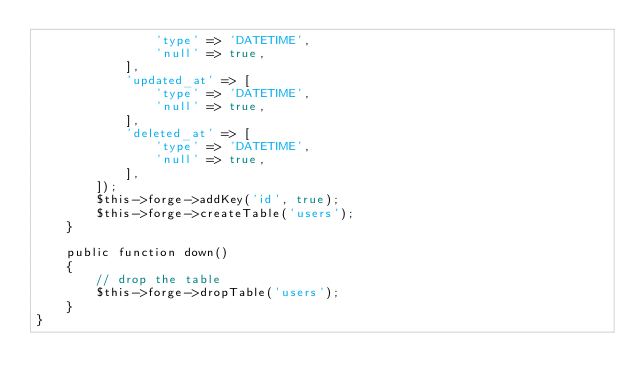<code> <loc_0><loc_0><loc_500><loc_500><_PHP_>                'type' => 'DATETIME',
                'null' => true,
            ],
            'updated_at' => [
                'type' => 'DATETIME',
                'null' => true,
            ],
            'deleted_at' => [
                'type' => 'DATETIME',
                'null' => true,
            ],
        ]);
        $this->forge->addKey('id', true);
        $this->forge->createTable('users');
    }

    public function down()
    {
        // drop the table
        $this->forge->dropTable('users');
    }
}
</code> 